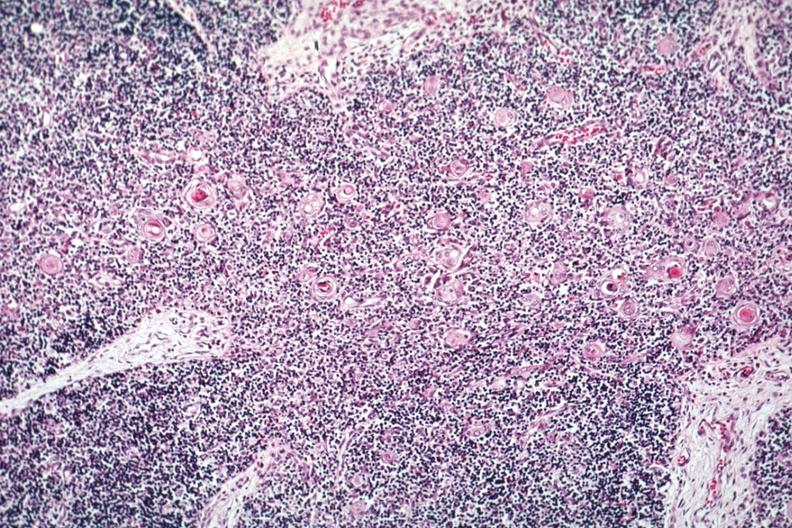what is present?
Answer the question using a single word or phrase. Normal immature infant 